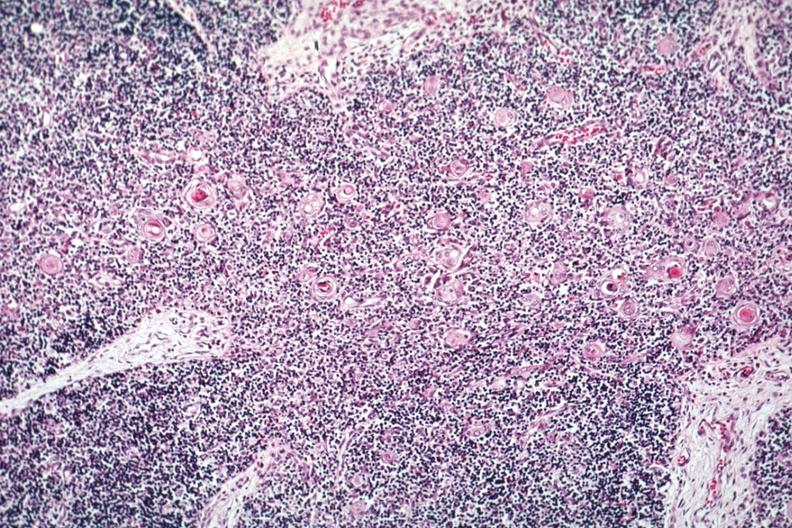what is present?
Answer the question using a single word or phrase. Normal immature infant 